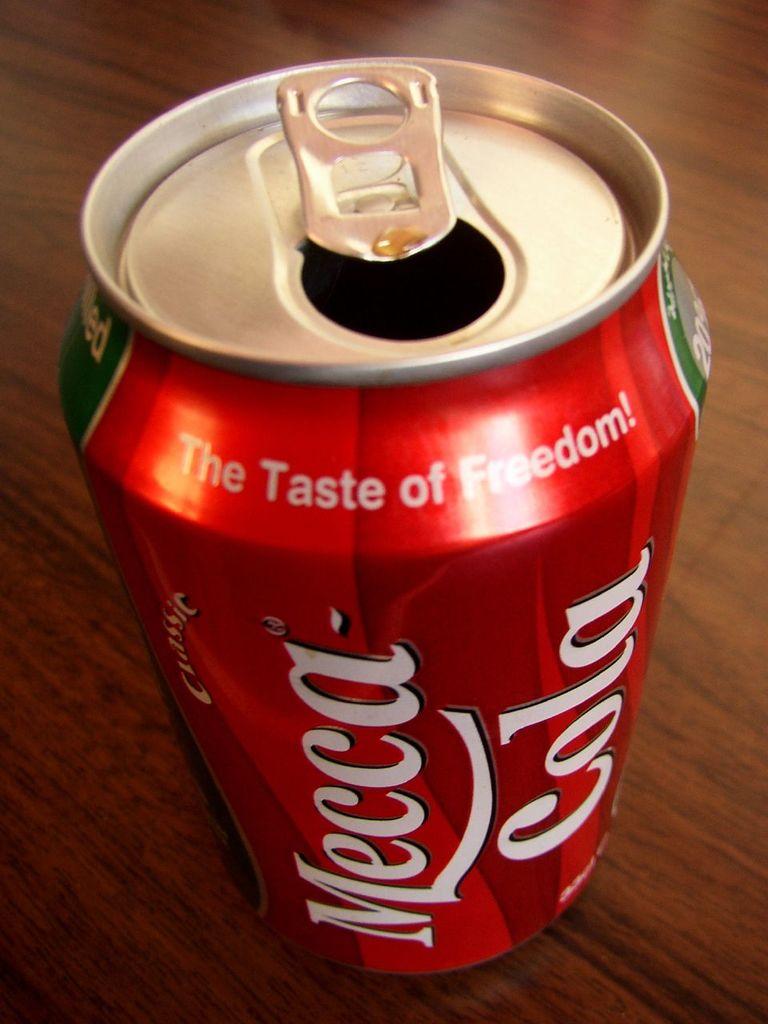What is the tagline for the soda?
Your answer should be very brief. The taste of freedom. 